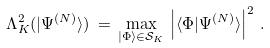Convert formula to latex. <formula><loc_0><loc_0><loc_500><loc_500>\Lambda _ { K } ^ { 2 } ( | \Psi ^ { ( N ) } \rangle ) \, = \, \max _ { | \Phi \rangle \in { \mathcal { S } } _ { K } } \, \left | \langle \Phi | \Psi ^ { ( N ) } \rangle \right | ^ { 2 } \, .</formula> 